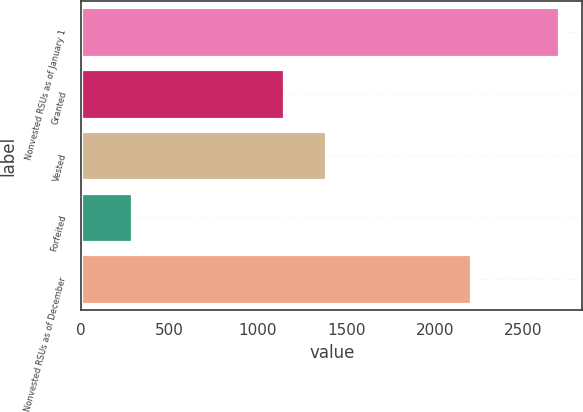Convert chart. <chart><loc_0><loc_0><loc_500><loc_500><bar_chart><fcel>Nonvested RSUs as of January 1<fcel>Granted<fcel>Vested<fcel>Forfeited<fcel>Nonvested RSUs as of December<nl><fcel>2698<fcel>1145<fcel>1386.1<fcel>287<fcel>2201<nl></chart> 